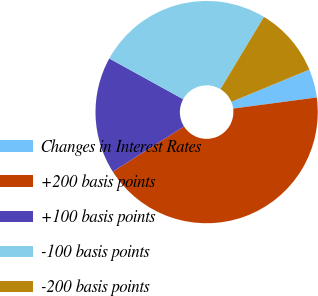<chart> <loc_0><loc_0><loc_500><loc_500><pie_chart><fcel>Changes in Interest Rates<fcel>+200 basis points<fcel>+100 basis points<fcel>-100 basis points<fcel>-200 basis points<nl><fcel>4.14%<fcel>43.1%<fcel>17.01%<fcel>25.61%<fcel>10.13%<nl></chart> 